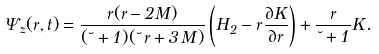Convert formula to latex. <formula><loc_0><loc_0><loc_500><loc_500>\Psi _ { z } ( r , t ) = \frac { r ( r - 2 M ) } { ( \lambda + 1 ) ( \lambda \, r + 3 \, M ) } \left ( H _ { 2 } - r \frac { \partial K } { \partial r } \right ) + \frac { r } { \lambda + 1 } K .</formula> 